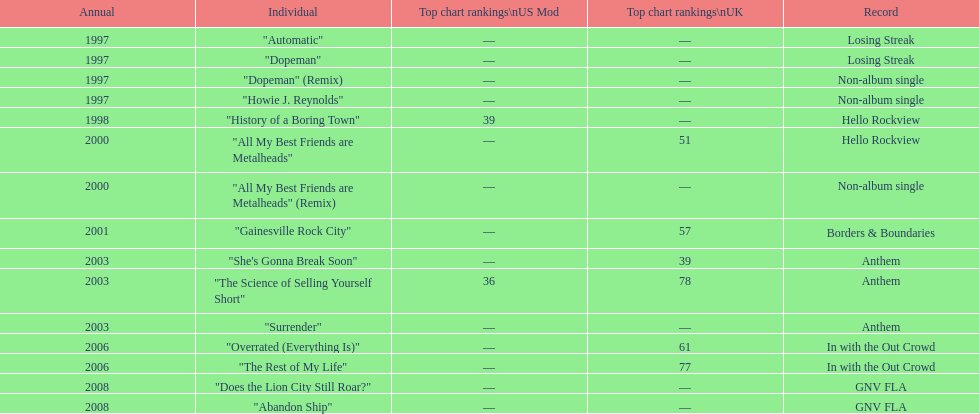Name one other single that was on the losing streak album besides "dopeman". "Automatic". 